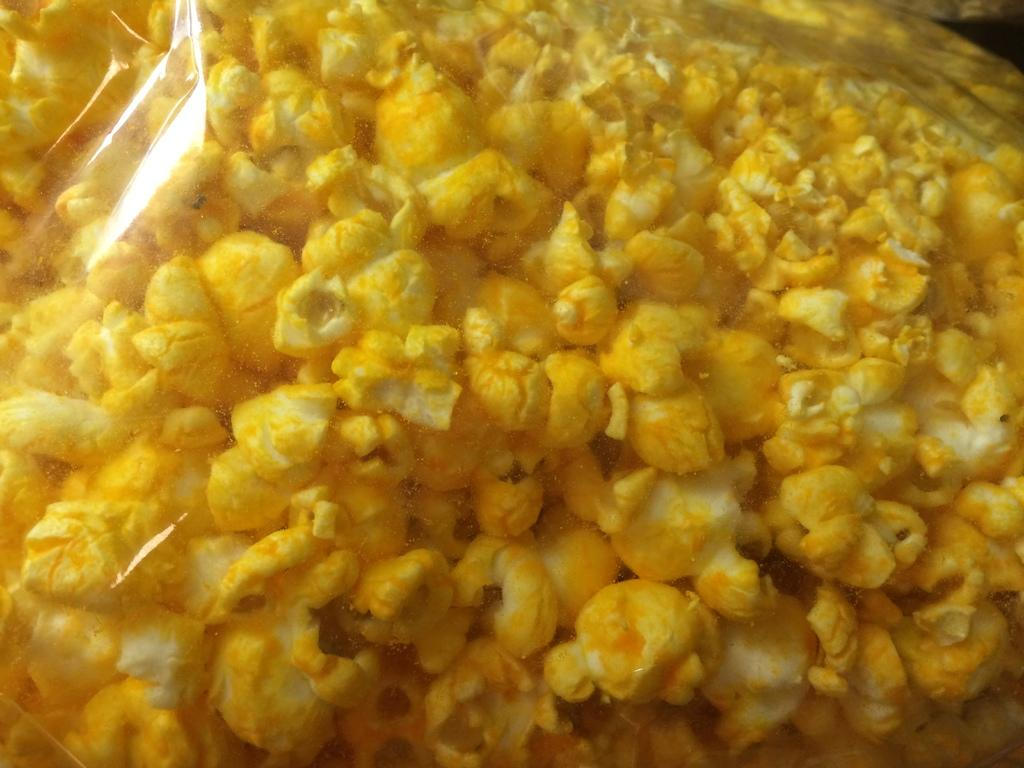What type of food is visible in the image? There is popcorn in the image. How is the popcorn contained or packaged? The popcorn is packed in a plastic cover. What type of basin is used to serve the popcorn in the image? There is no basin present in the image; the popcorn is packed in a plastic cover. What class is being taught in the image? There is no class or educational setting depicted in the image; it features popcorn packed in a plastic cover. 